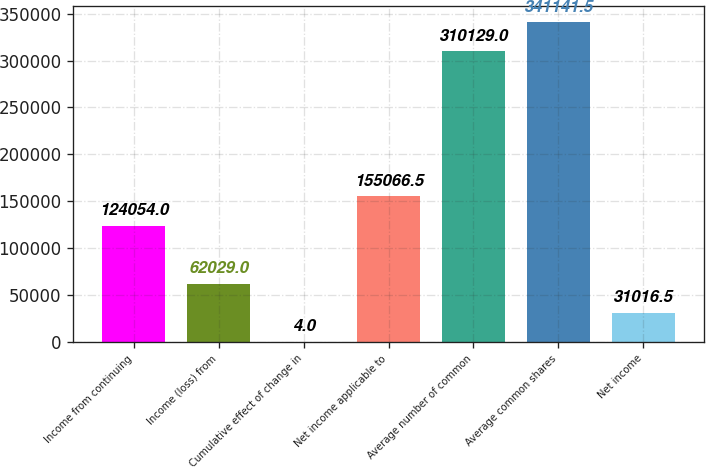<chart> <loc_0><loc_0><loc_500><loc_500><bar_chart><fcel>Income from continuing<fcel>Income (loss) from<fcel>Cumulative effect of change in<fcel>Net income applicable to<fcel>Average number of common<fcel>Average common shares<fcel>Net income<nl><fcel>124054<fcel>62029<fcel>4<fcel>155066<fcel>310129<fcel>341142<fcel>31016.5<nl></chart> 